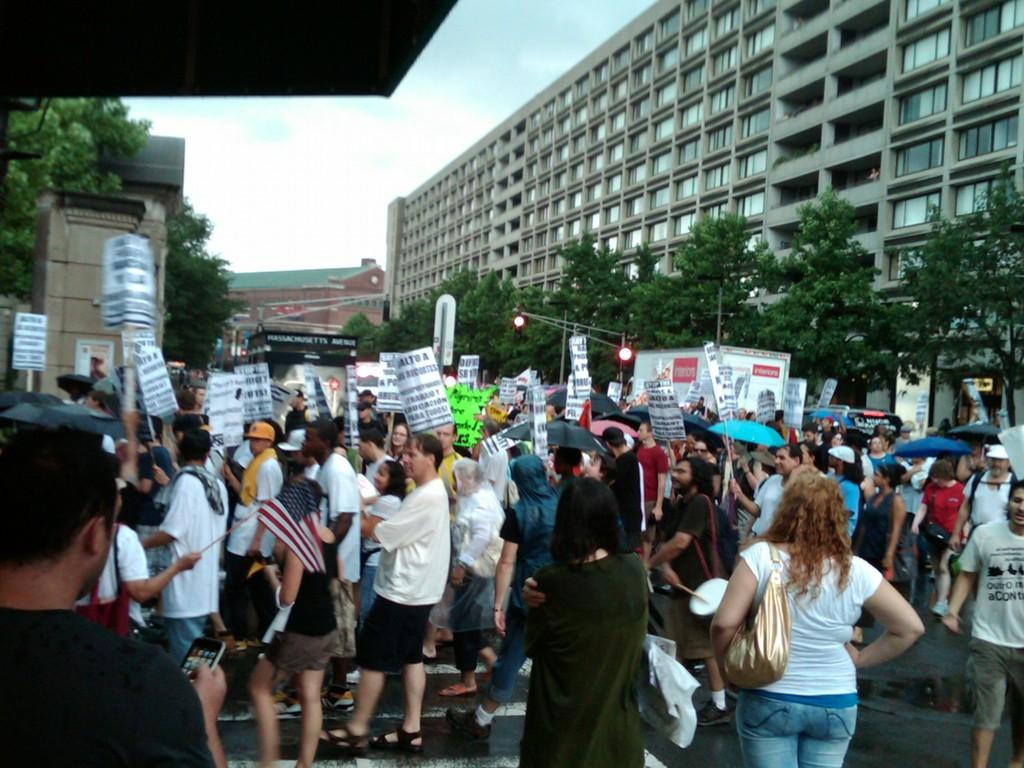How many people are in the image? There are people in the image, but the exact number is not specified. What are the people holding in the image? Some of the people are holding objects, but the specific objects are not mentioned. What type of structures can be seen in the image? There are buildings in the image. What other natural elements are present in the image? There are trees in the image. What type of street furniture can be seen in the image? There are light and poles in the image. What is visible in the background of the image? The sky with clouds is visible in the background. What year is the question being asked in the image? There is no question being asked in the image, nor is there any indication of the year. What type of top is being worn by the people in the image? The facts provided do not mention any clothing or specific details about the people's attire. 